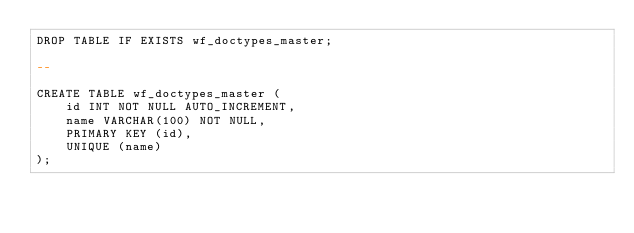<code> <loc_0><loc_0><loc_500><loc_500><_SQL_>DROP TABLE IF EXISTS wf_doctypes_master;

--

CREATE TABLE wf_doctypes_master (
    id INT NOT NULL AUTO_INCREMENT,
    name VARCHAR(100) NOT NULL,
    PRIMARY KEY (id),
    UNIQUE (name)
);
</code> 